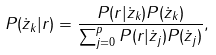Convert formula to latex. <formula><loc_0><loc_0><loc_500><loc_500>P ( \dot { z } _ { k } | r ) = \frac { P ( r | \dot { z } _ { k } ) P ( \dot { z } _ { k } ) } { \sum _ { j = 0 } ^ { p } P ( r | \dot { z } _ { j } ) P ( \dot { z } _ { j } ) } ,</formula> 